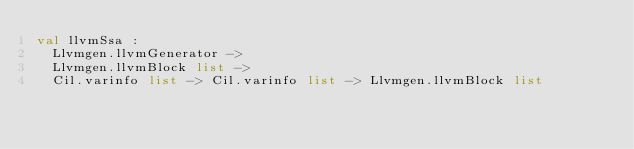<code> <loc_0><loc_0><loc_500><loc_500><_OCaml_>val llvmSsa :
  Llvmgen.llvmGenerator ->
  Llvmgen.llvmBlock list ->
  Cil.varinfo list -> Cil.varinfo list -> Llvmgen.llvmBlock list
</code> 